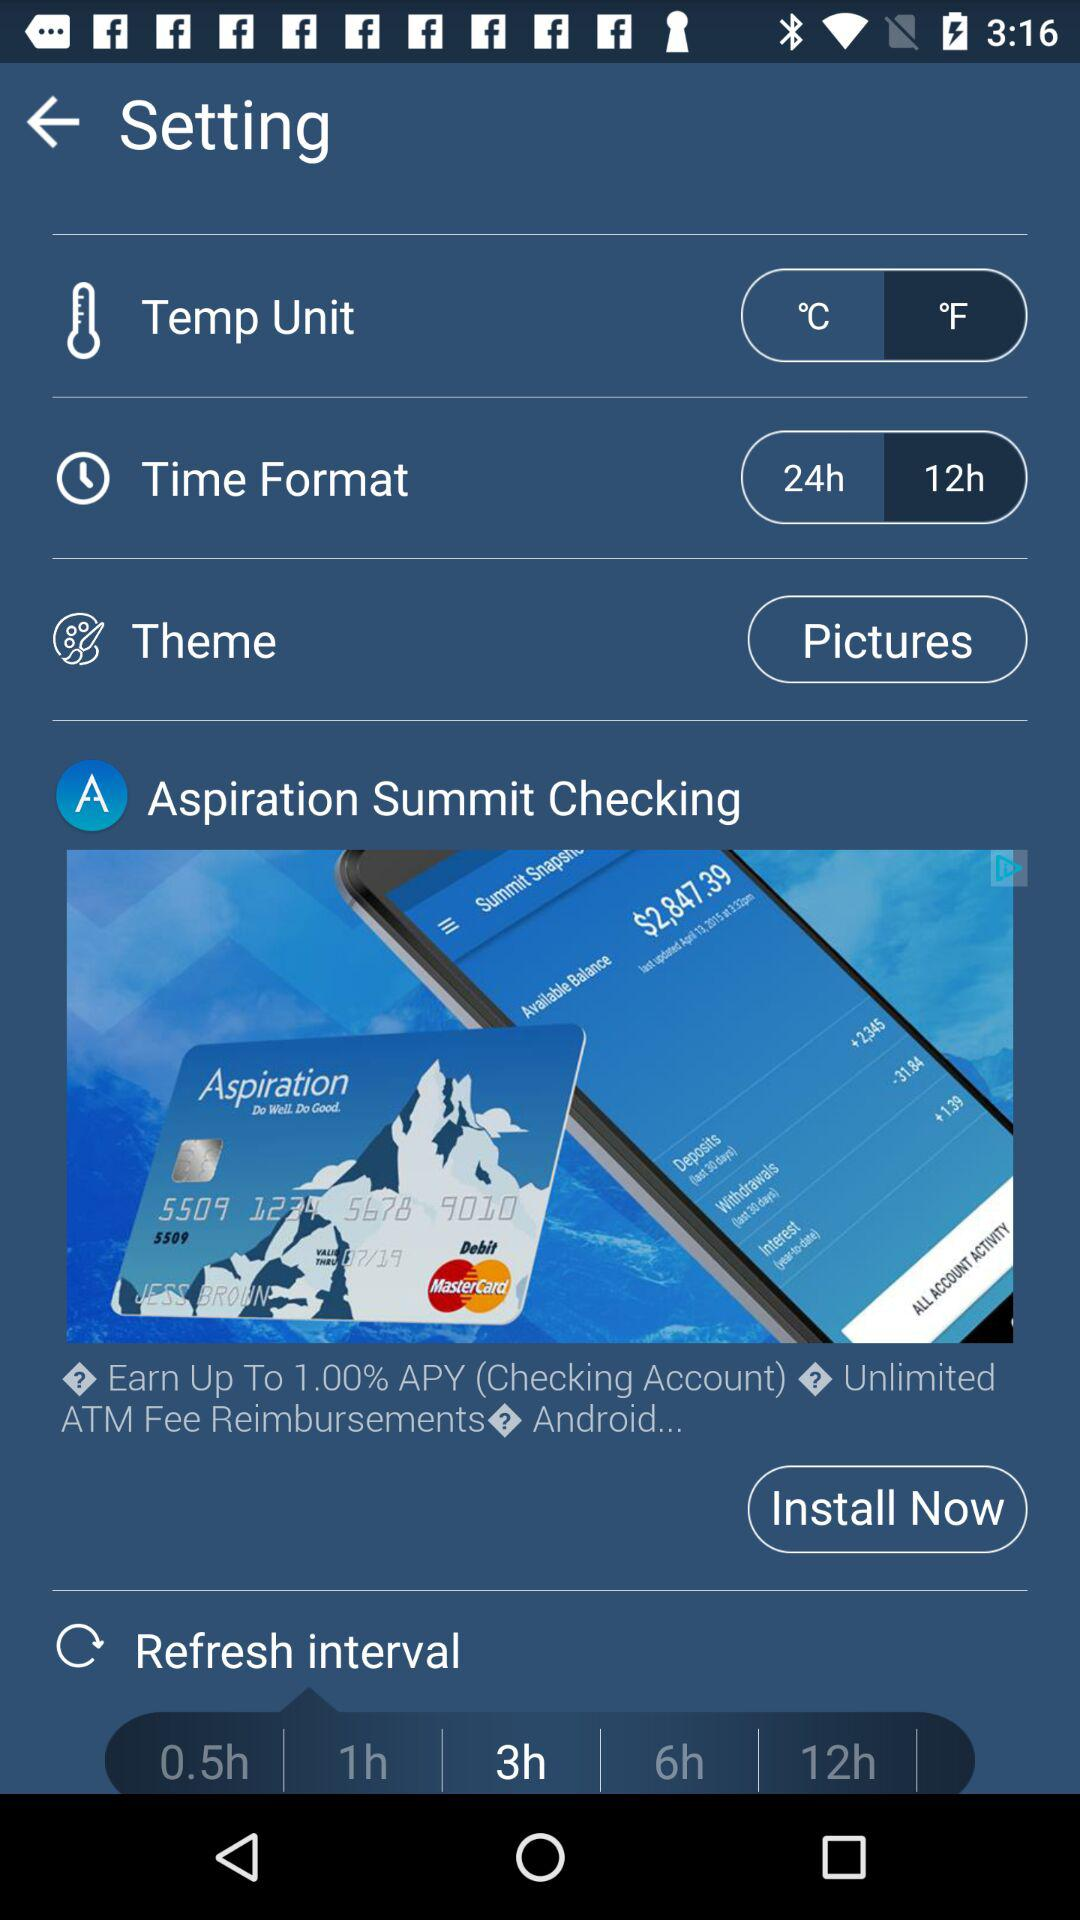Which time format is selected? The selected time format is 12 hours. 